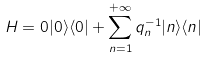Convert formula to latex. <formula><loc_0><loc_0><loc_500><loc_500>H = 0 | 0 \rangle \langle 0 | + \sum _ { n = 1 } ^ { + \infty } q _ { n } ^ { - 1 } | n \rangle \langle n |</formula> 